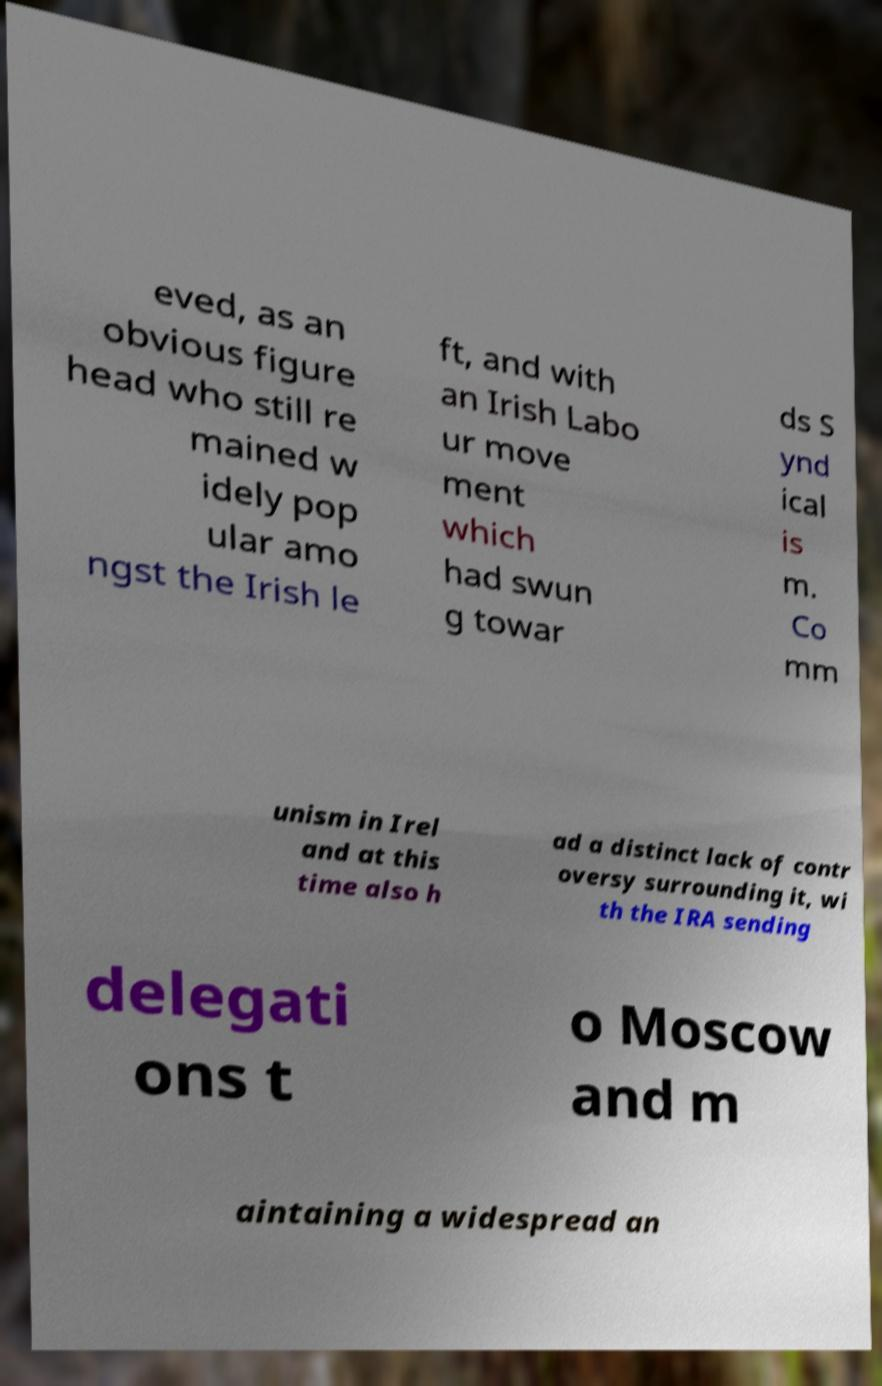Could you extract and type out the text from this image? eved, as an obvious figure head who still re mained w idely pop ular amo ngst the Irish le ft, and with an Irish Labo ur move ment which had swun g towar ds S ynd ical is m. Co mm unism in Irel and at this time also h ad a distinct lack of contr oversy surrounding it, wi th the IRA sending delegati ons t o Moscow and m aintaining a widespread an 